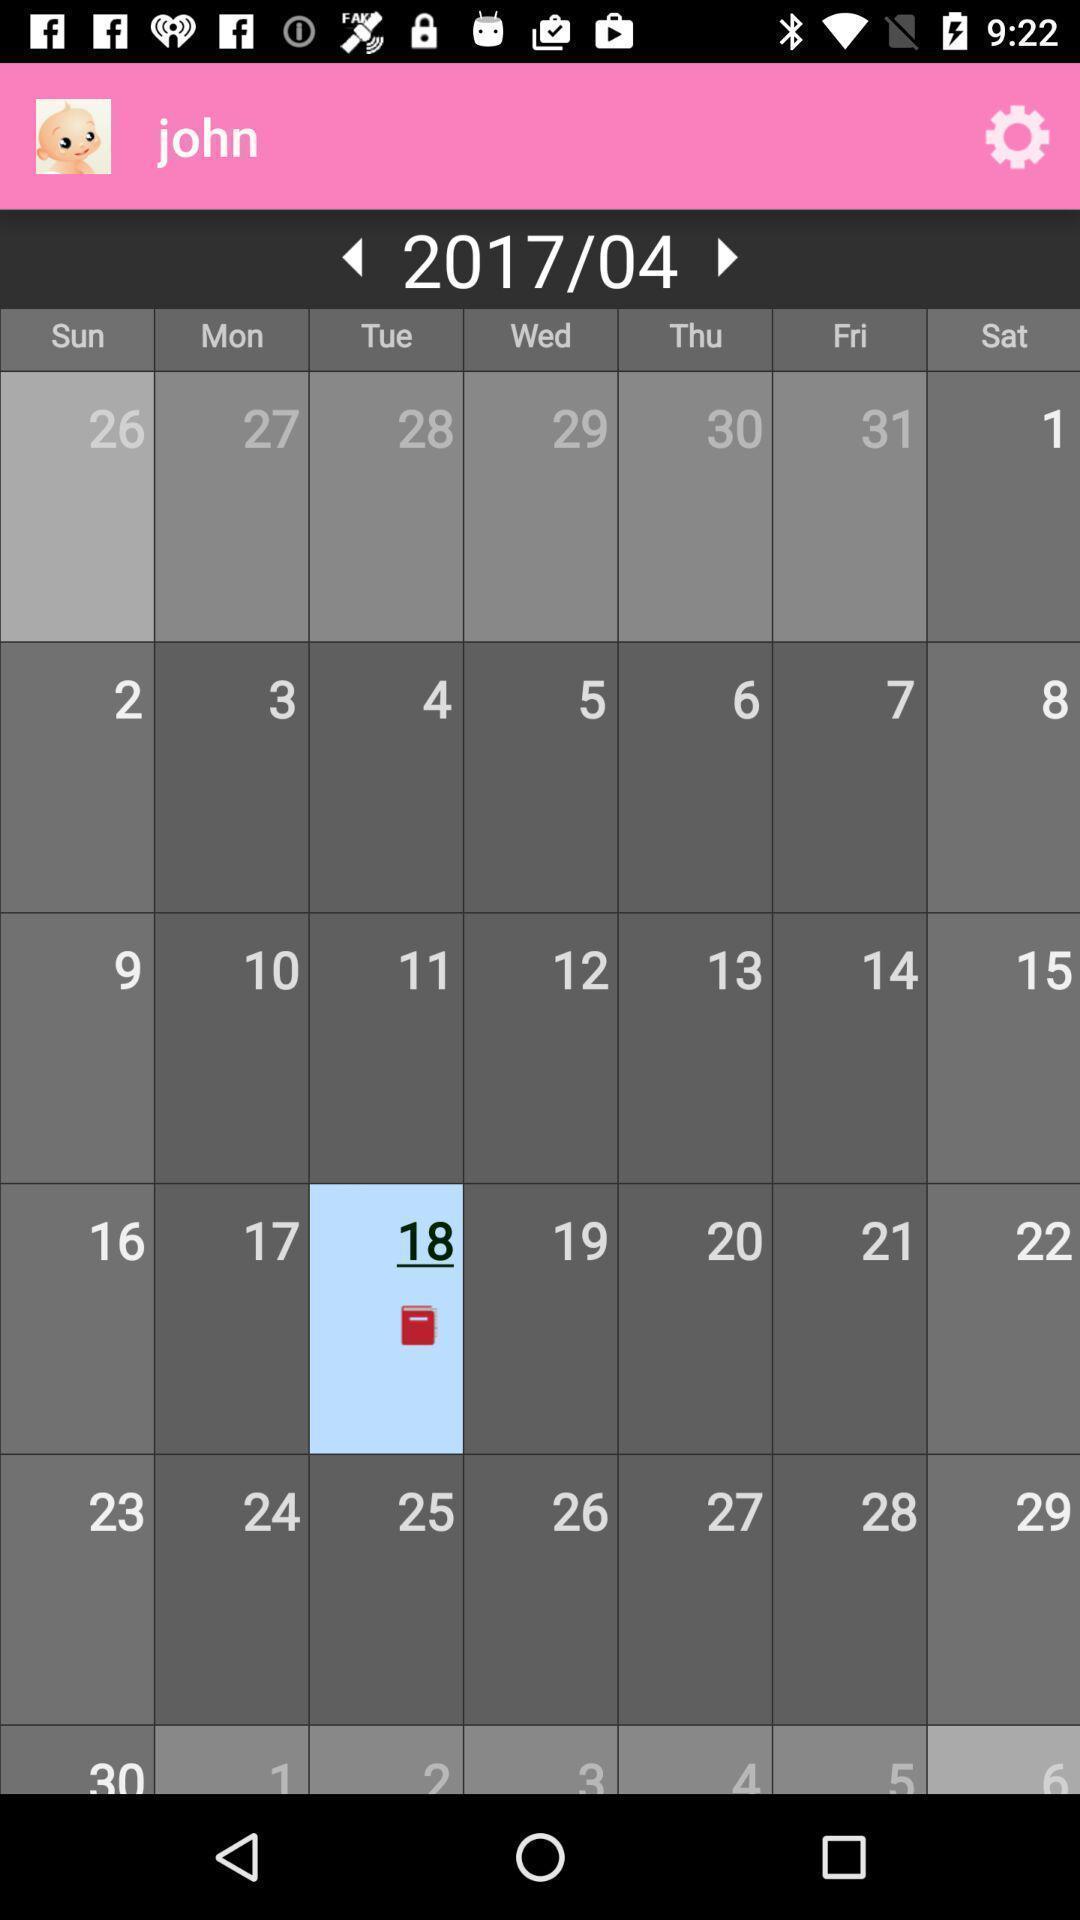Explain the elements present in this screenshot. Page displaying to select date in calendar. 